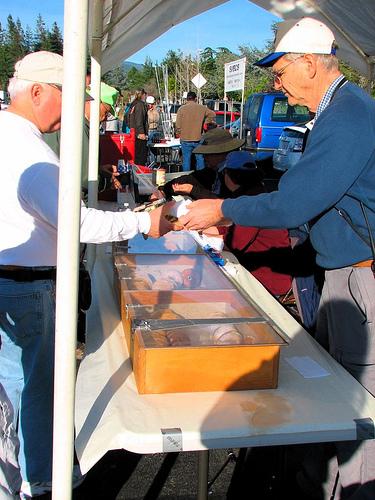What is being sold here?
Quick response, please. Food. Are there any condiments?
Give a very brief answer. No. Does this look like someone just bought something?
Short answer required. Yes. What color are their hats?
Write a very short answer. White. Is it a sunny day?
Be succinct. Yes. 